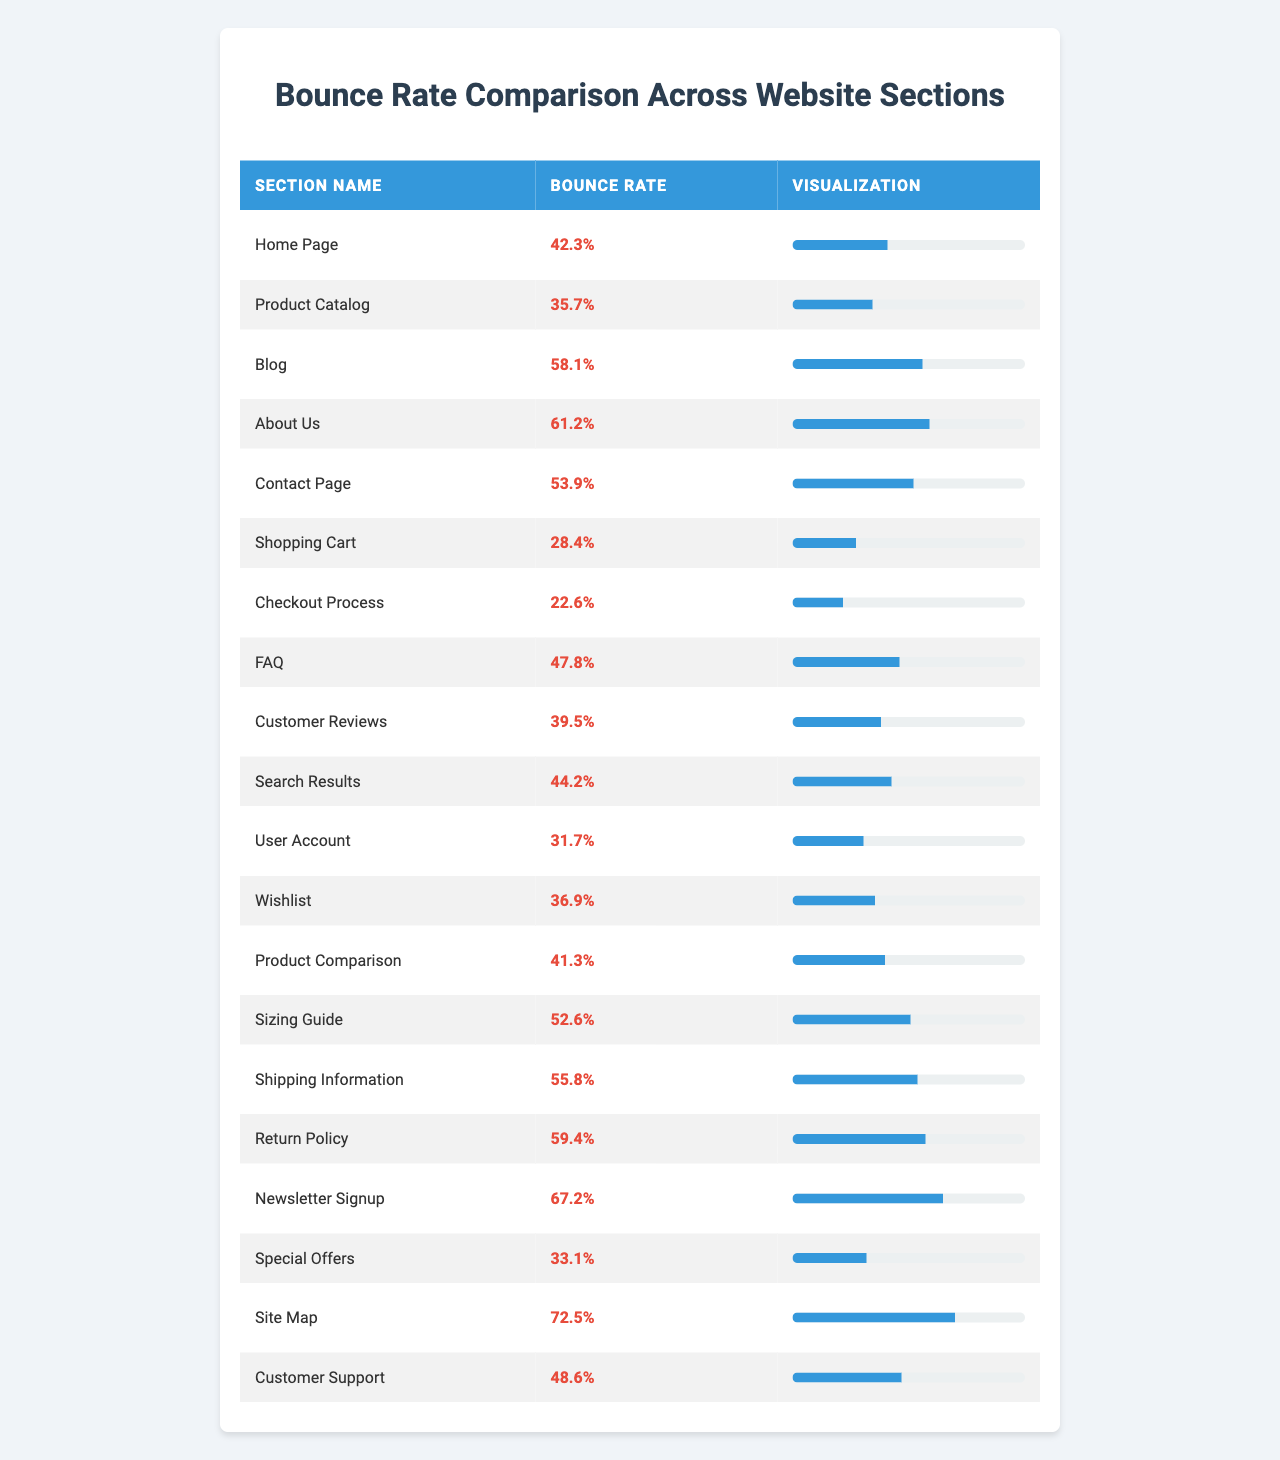What is the bounce rate for the 'Blog' section? The table lists the bounce rate for each section, and for the 'Blog' section, it shows a bounce rate of 58.1%.
Answer: 58.1% Which website section has the lowest bounce rate? By inspecting the table, the 'Checkout Process' section shows the lowest bounce rate at 22.6%.
Answer: 22.6% What is the bounce rate difference between the 'Home Page' and 'About Us' sections? The bounce rate for 'Home Page' is 42.3% and for 'About Us' it is 61.2%. The difference is 61.2% - 42.3% = 18.9%.
Answer: 18.9% Is the bounce rate for the 'Contact Page' higher than the average bounce rate of the 'Product Catalog' and 'User Account' sections? The bounce rates for 'Product Catalog' and 'User Account' are 35.7% and 31.7% respectively. The average is (35.7% + 31.7%) / 2 = 33.7%. Since the 'Contact Page' bounce rate is 53.9%, it is indeed higher.
Answer: Yes Calculate the average bounce rate for the 'Shipping Information', 'Return Policy', and 'Newsletter Signup' sections. The bounce rates for these sections are 55.8%, 59.4%, and 67.2%. The sum is 55.8% + 59.4% + 67.2% = 182.4%. Dividing by 3 gives an average of 182.4% / 3 ≈ 60.8%.
Answer: 60.8% How many sections have a bounce rate above 50%? By reviewing the table, the sections with bounce rates above 50% are 'About Us' (61.2%), 'Contact Page' (53.9%), 'Sizing Guide' (52.6%), 'Shipping Information' (55.8%), 'Return Policy' (59.4%), 'Newsletter Signup' (67.2%), and 'Site Map' (72.5%). Counting these gives us 7 sections.
Answer: 7 Which section has a higher bounce rate, 'Wishlist' or 'Customer Reviews'? The bounce rate for 'Wishlist' is 36.9% and for 'Customer Reviews' it is 39.5%. Comparing both, 39.5% (Customer Reviews) is greater than 36.9% (Wishlist).
Answer: Customer Reviews What is the combined bounce rate of the 'User Account', 'Wishlist', and 'Shopping Cart' sections? The bounce rates are 31.7% (User Account), 36.9% (Wishlist), and 28.4% (Shopping Cart). Adding these up gives 31.7% + 36.9% + 28.4% = 96.9%.
Answer: 96.9% Is the bounce rate for the 'Site Map' higher than that of the 'Special Offers'? The bounce rate for the 'Site Map' is 72.5% and for 'Special Offers', it is 33.1%. Since 72.5% is greater than 33.1%, the 'Site Map' bounce rate is higher.
Answer: Yes What is the difference in bounce rates between the 'Shipping Information' and 'FAQ' sections? The bounce rate for 'Shipping Information' is 55.8% and for 'FAQ' it is 47.8%. Thus, the difference is 55.8% - 47.8% = 8%.
Answer: 8% 